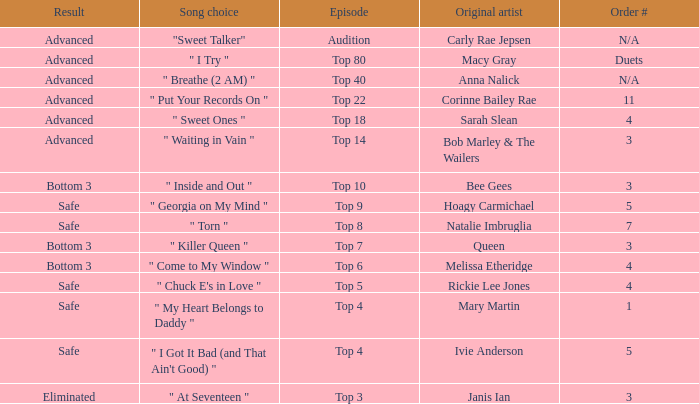What's the order number of the song originally performed by Rickie Lee Jones? 4.0. 